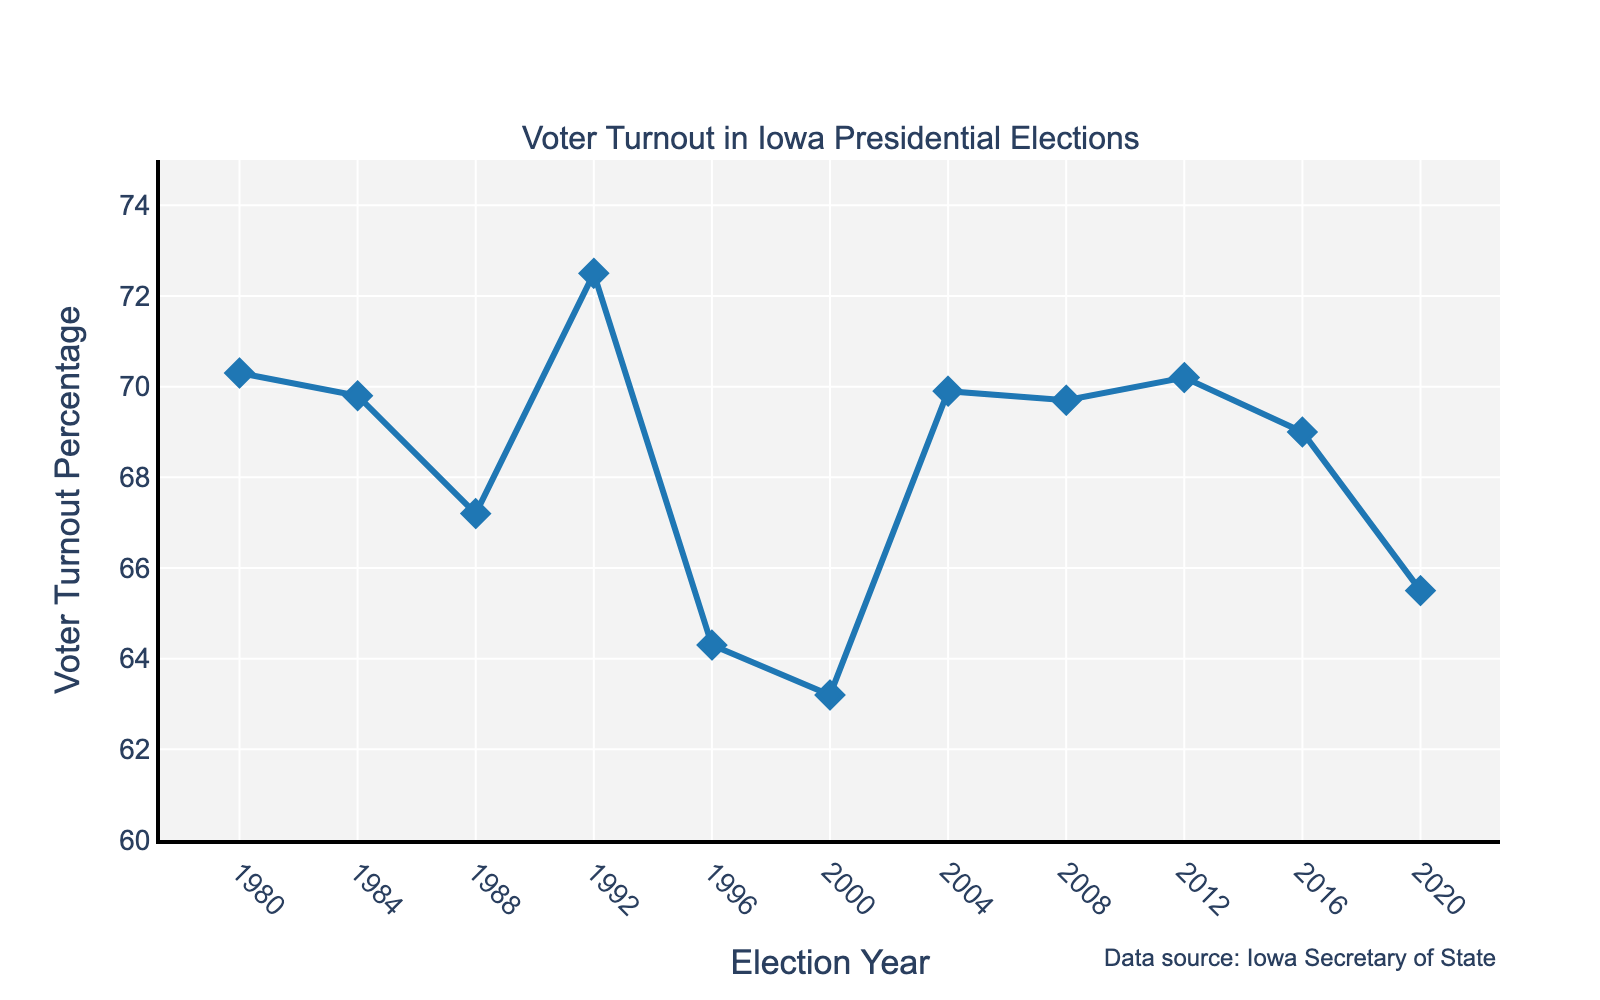What was the voter turnout percentage in the year 2000? To find the voter turnout percentage for the year 2000, locate the 2000 marker on the x-axis and see where the corresponding point on the line chart lies on the y-axis.
Answer: 63.2 Compare the voter turnout percentages between 1992 and 1996. Which year had a higher turnout? Locate the years 1992 and 1996 on the x-axis and compare their corresponding points on the y-axis. The point for 1992 is higher than that for 1996.
Answer: 1992 What is the difference in voter turnout percentage between the year with the highest turnout and the year with the lowest turnout? Identify the years with the highest and lowest turnouts by looking at the highest and lowest points on the line. The highest is 1992 at 72.5%, and the lowest is 2000 at 63.2%. Subtract 63.2 from 72.5 to get the difference.
Answer: 9.3 Which election year had a voter turnout percentage of 70.3%? Scan through the y-axis values and locate 70.3%, then trace it back along the line chart to find the corresponding x-axis value (year).
Answer: 1980 What is the average voter turnout percentage for the election years 2008, 2012, and 2016? Locate the voter turnout percentages for the years 2008 (69.7%), 2012 (70.2%), and 2016 (69.0%). Add these values (69.7 + 70.2 + 69.0) and divide by 3 to find the average.
Answer: 69.63 How did the voter turnout change from 1980 to 1984? Compare the points for 1980 and 1984. The 1980 voter turnout percentage was 70.3%, and for 1984, it was 69.8%. Subtract 69.8 from 70.3 to find the change.
Answer: -0.5 Which years had a voter turnout percentage higher than 70%? Identify the points on the y-axis that are above 70% and find their corresponding x-axis values (years).
Answer: 1980, 1992, 2012 What trend do you observe in voter turnout percentages between 1988 and 1996? Look at the line segment between 1988 and 1996. The voter turnout decreases from 67.2% in 1988 to 64.3% in 1996.
Answer: Decreasing What is the median voter turnout percentage among all the years presented? Order all the voter turnout percentages: 63.2, 64.3, 65.5, 67.2, 69.0, 69.7, 69.8, 69.9, 70.2, 70.3, 72.5. With 11 data points, the median is the 6th value, which is 69.0%.
Answer: 69.0 How many years had a voter turnout percentage lower than 65%? Identify the years with points below 65% on the y-axis. The years 1996 (64.3%) and 2000 (63.2%) are below 65%.
Answer: 2 